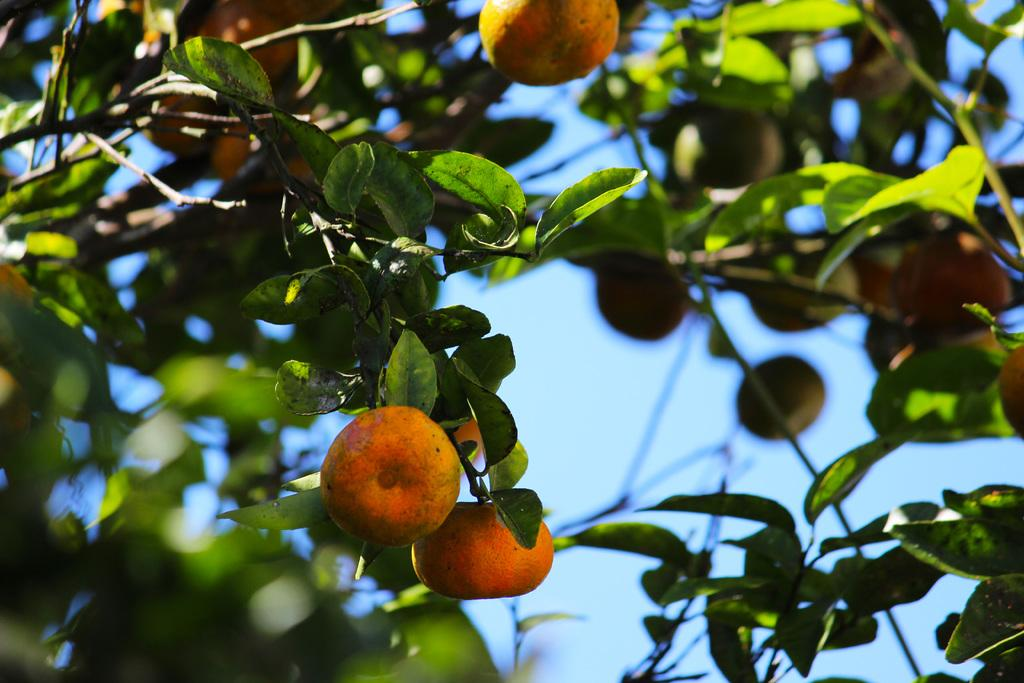What type of food can be seen in the image? There are fruits in the image. What natural elements are present in the image? There are trees in the image. What type of silver object can be seen in the image? There is no silver object present in the image. How many cents are visible on the ground in the image? There are no cents visible in the image. 